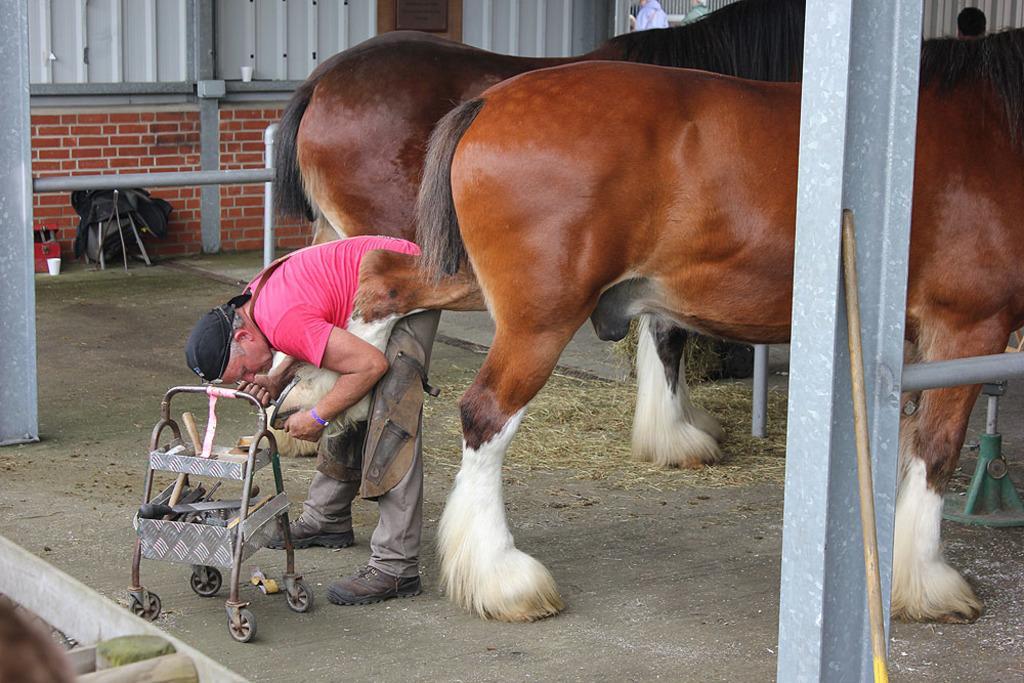Please provide a concise description of this image. In this image we can see horses. There is a person wearing pink color T-shirt. There is a trolley with some objects in it. At the bottom of the image there is floor. In the background of the image there is wall. There are rods. 